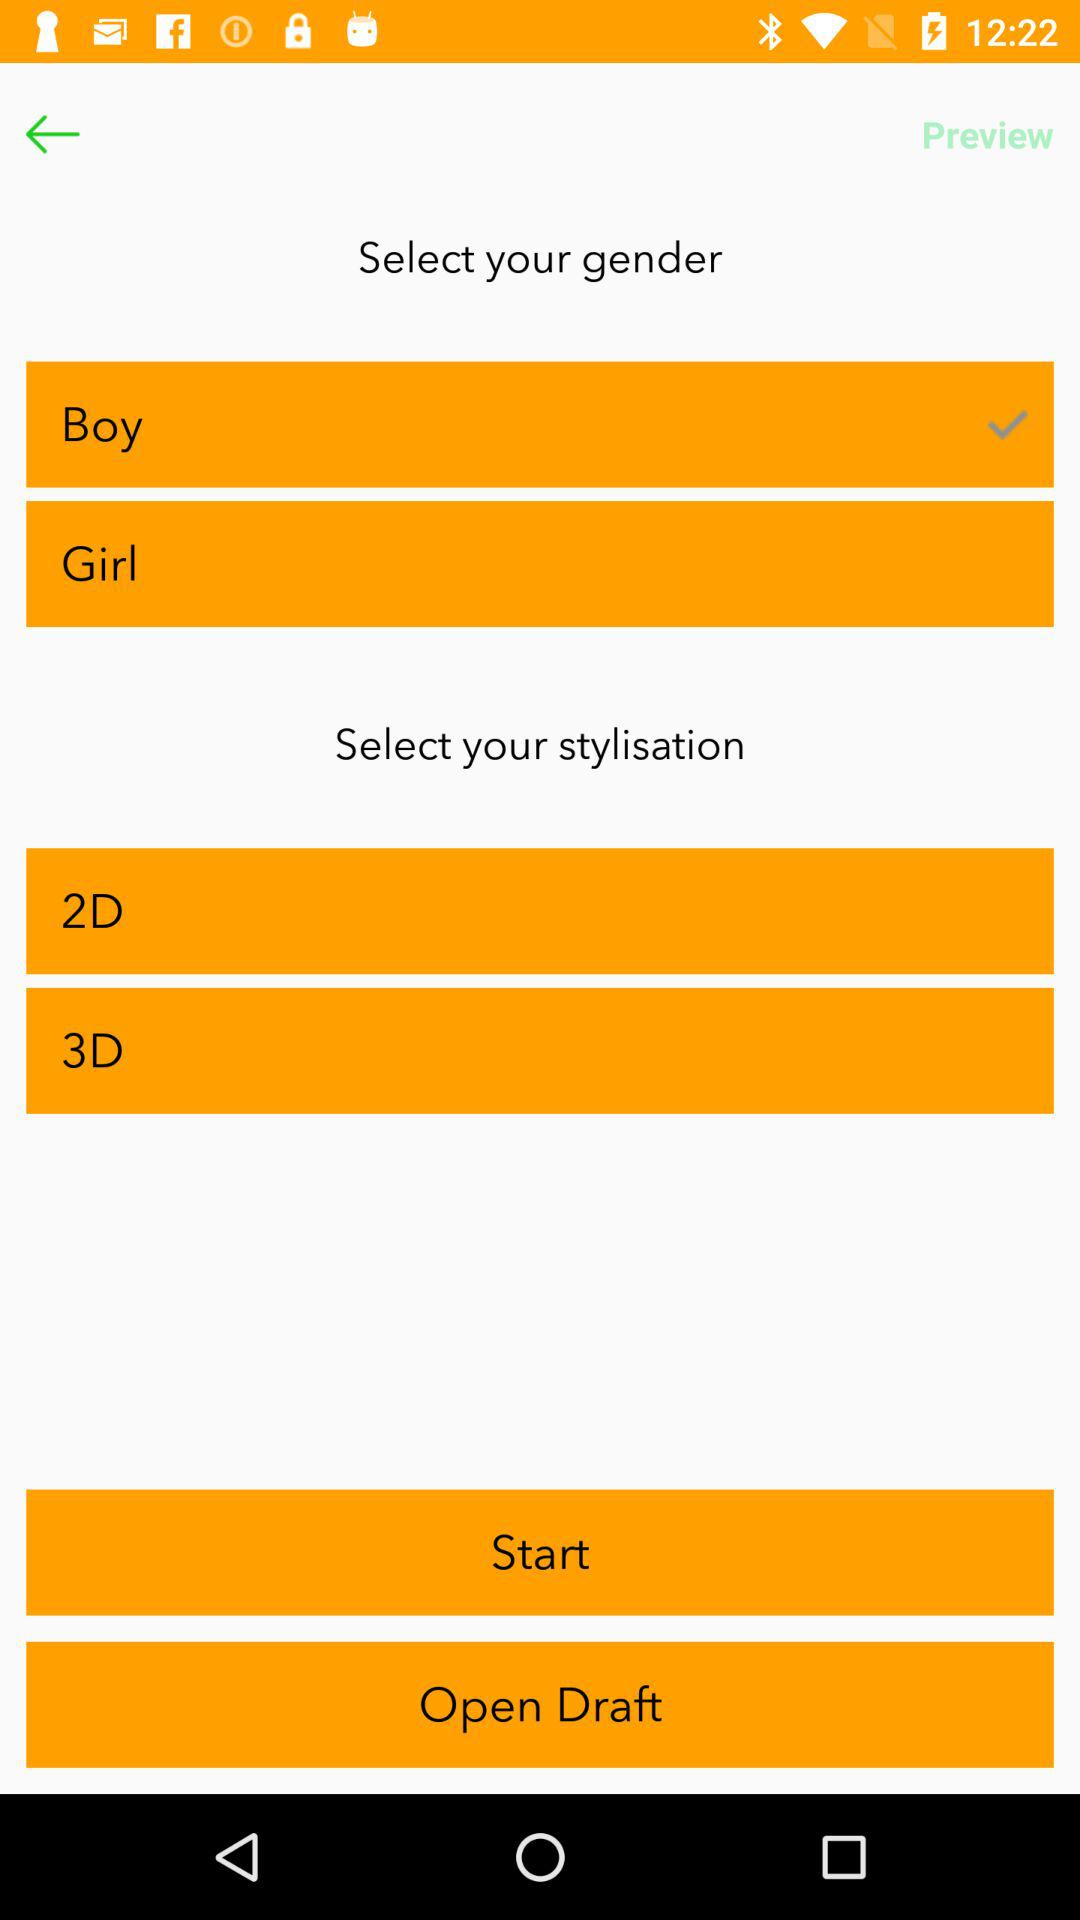Which option has been selected in "Select your gender"? The option that has been selected in "Select your gender" is "Boy". 